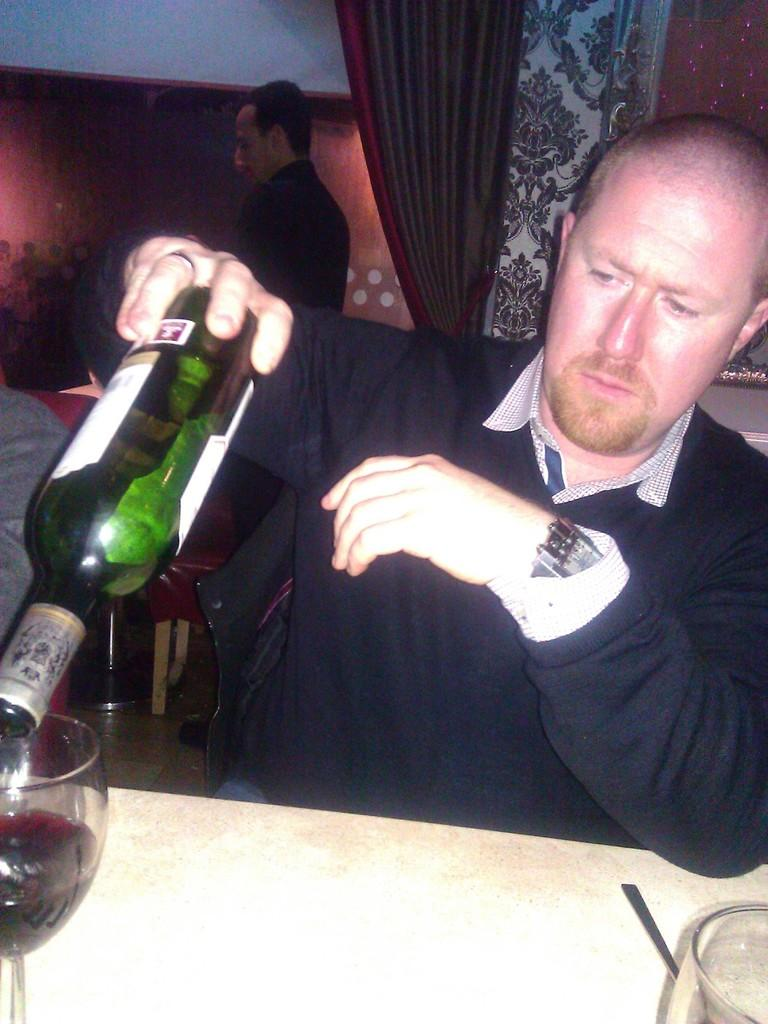What is the man in the image holding? The man is holding a bottle in the image. What is present on the table in the image? There are glasses on the table in the image. What can be seen in the background of the image? There is a curtain and a wall in the background of the image. What is the man likely to do with the bottle he is holding? The man might pour the contents of the bottle into the glasses on the table. What type of cover is the girl wearing in the image? There is no girl present in the image, so it is not possible to answer the question about a cover. 